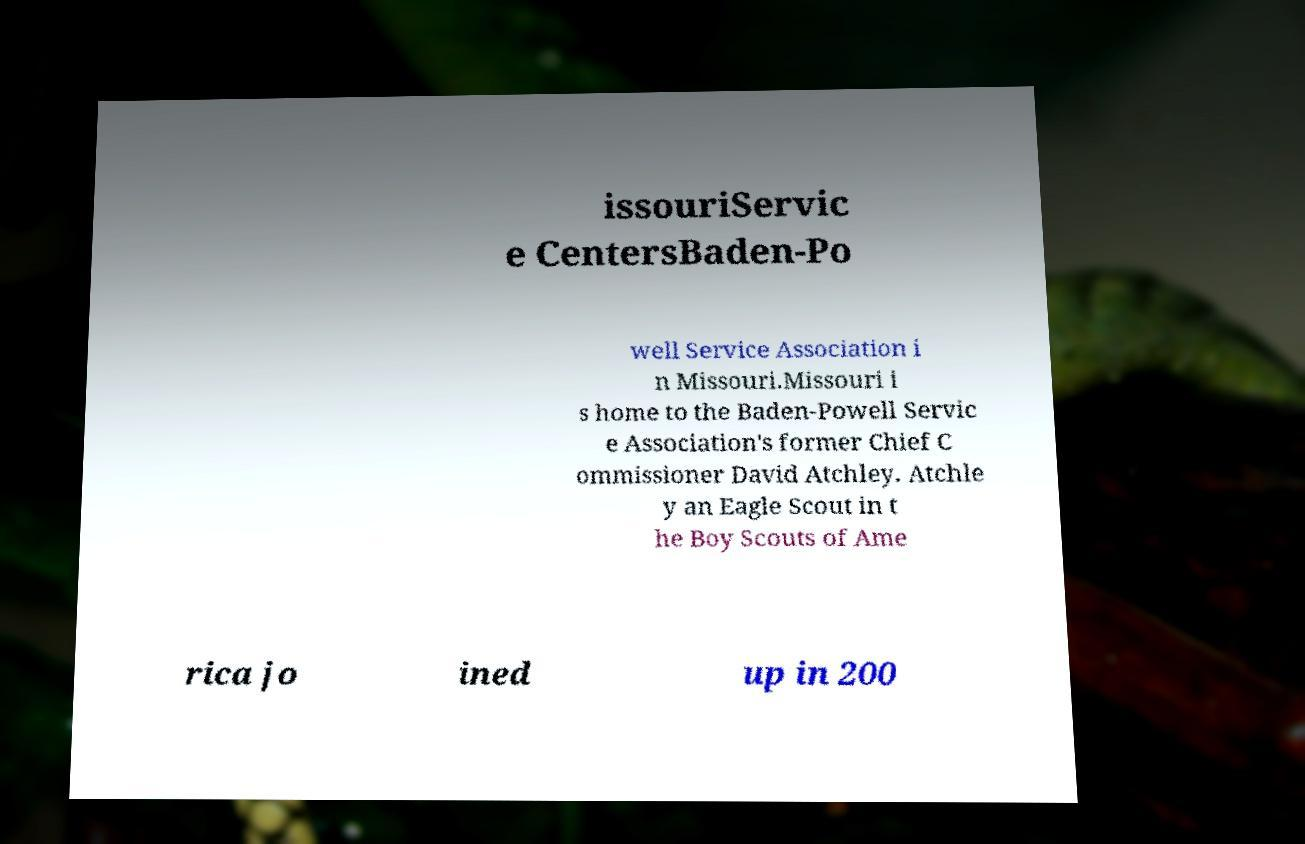For documentation purposes, I need the text within this image transcribed. Could you provide that? issouriServic e CentersBaden-Po well Service Association i n Missouri.Missouri i s home to the Baden-Powell Servic e Association's former Chief C ommissioner David Atchley. Atchle y an Eagle Scout in t he Boy Scouts of Ame rica jo ined up in 200 